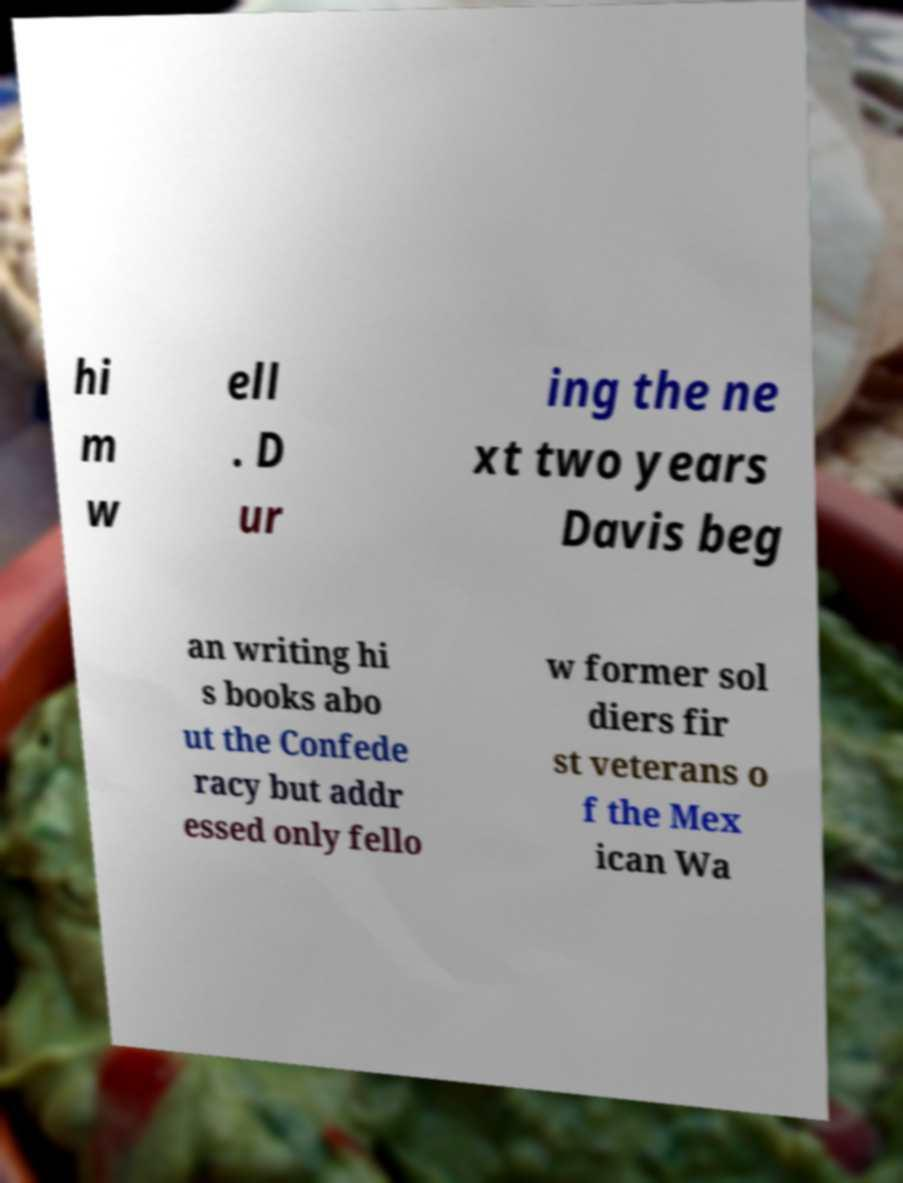I need the written content from this picture converted into text. Can you do that? hi m w ell . D ur ing the ne xt two years Davis beg an writing hi s books abo ut the Confede racy but addr essed only fello w former sol diers fir st veterans o f the Mex ican Wa 